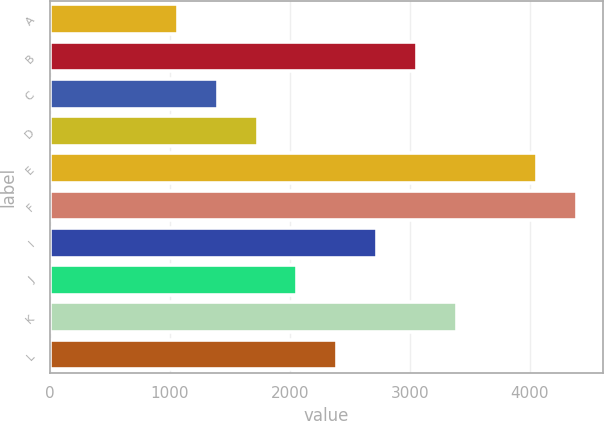Convert chart to OTSL. <chart><loc_0><loc_0><loc_500><loc_500><bar_chart><fcel>A<fcel>B<fcel>C<fcel>D<fcel>E<fcel>F<fcel>I<fcel>J<fcel>K<fcel>L<nl><fcel>1067.35<fcel>3059.47<fcel>1399.37<fcel>1731.39<fcel>4055.55<fcel>4387.57<fcel>2727.45<fcel>2063.41<fcel>3391.49<fcel>2395.43<nl></chart> 